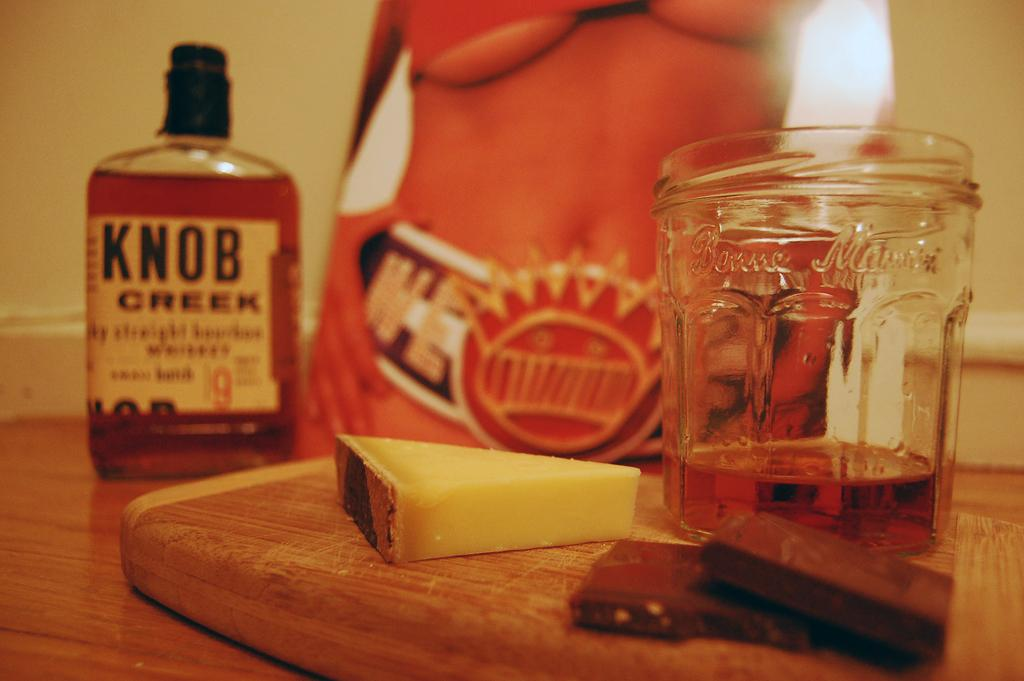Provide a one-sentence caption for the provided image. A close up view of a cheeseboard with a slice of cheese, some chocolate, a glass with partially filled whiskey, and a full bottle of Knob Creek whiskey. 